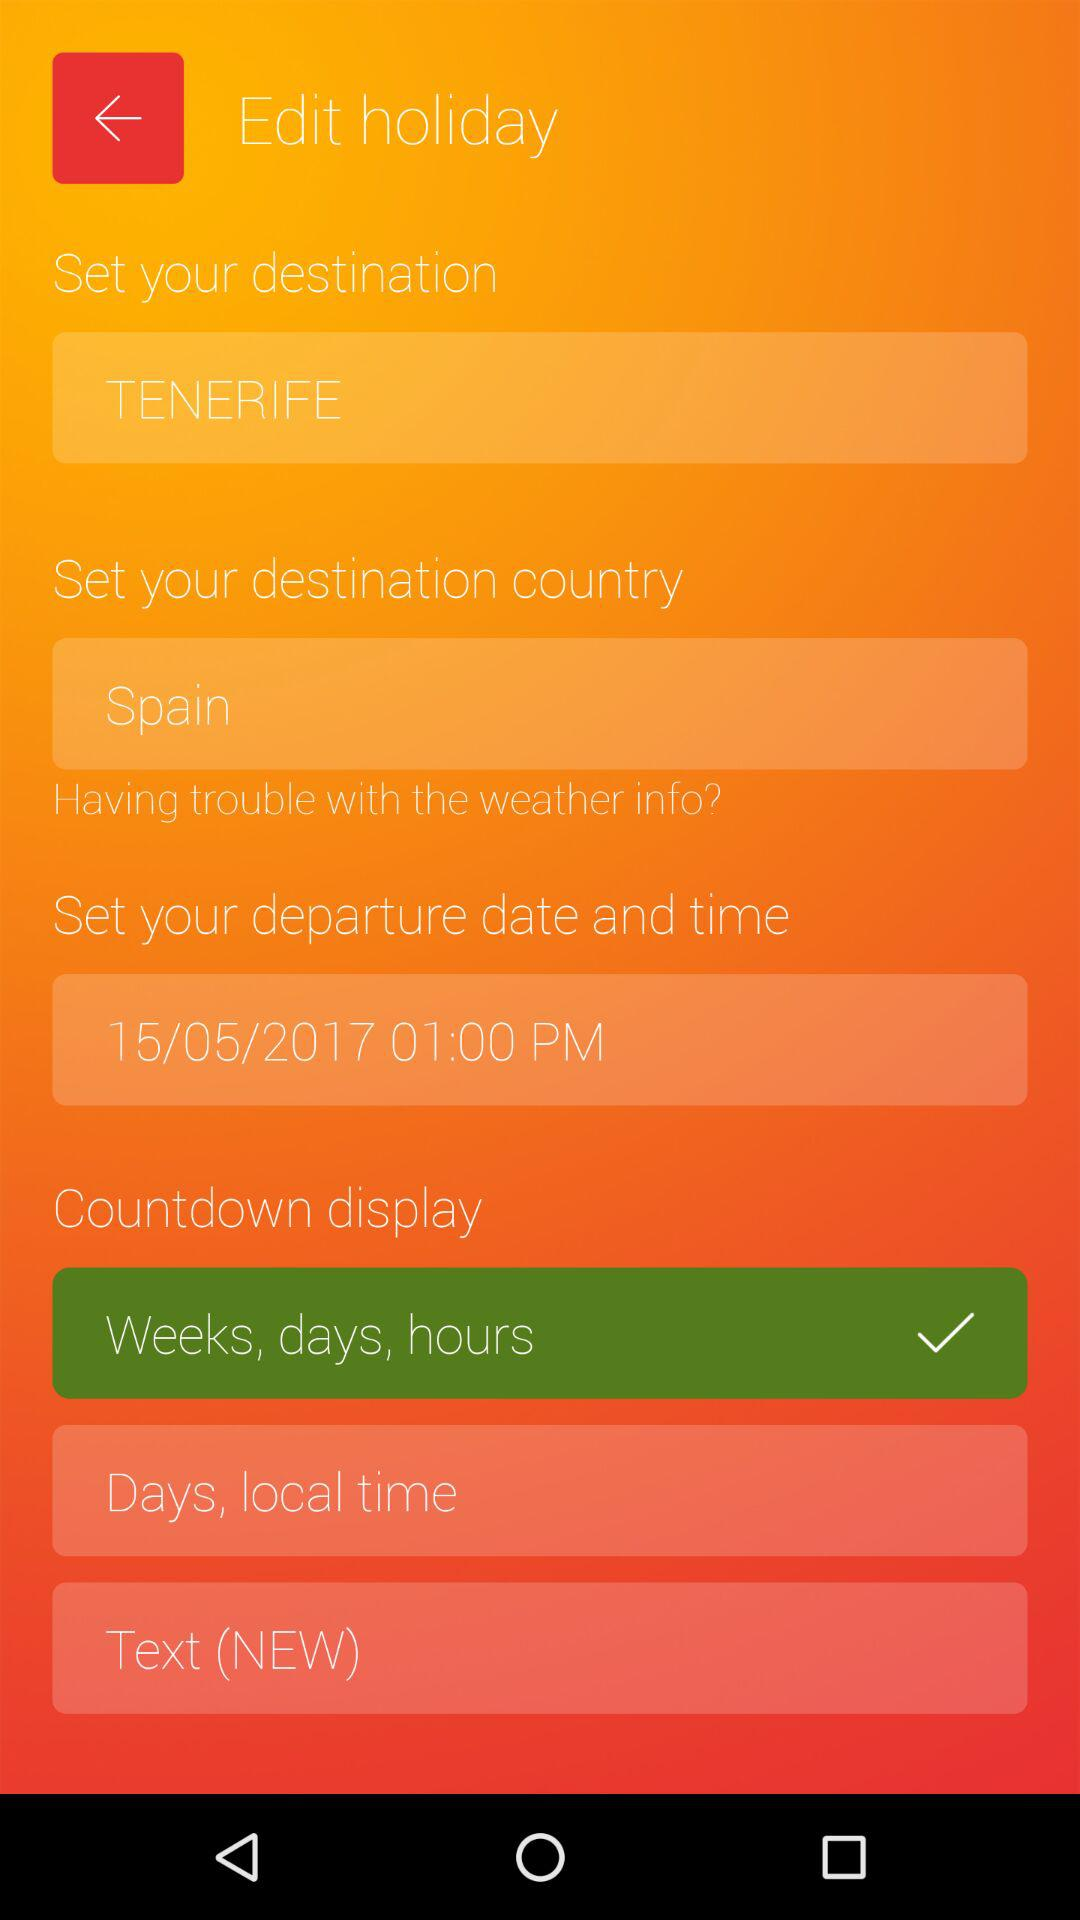What is the selected destination? The selected destination is Tenerife. 